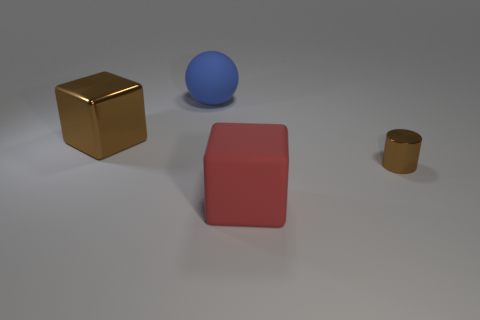Add 3 small brown metal spheres. How many objects exist? 7 Subtract all balls. How many objects are left? 3 Add 4 blue spheres. How many blue spheres are left? 5 Add 2 big yellow rubber balls. How many big yellow rubber balls exist? 2 Subtract 0 cyan cylinders. How many objects are left? 4 Subtract all tiny brown metallic things. Subtract all large brown matte blocks. How many objects are left? 3 